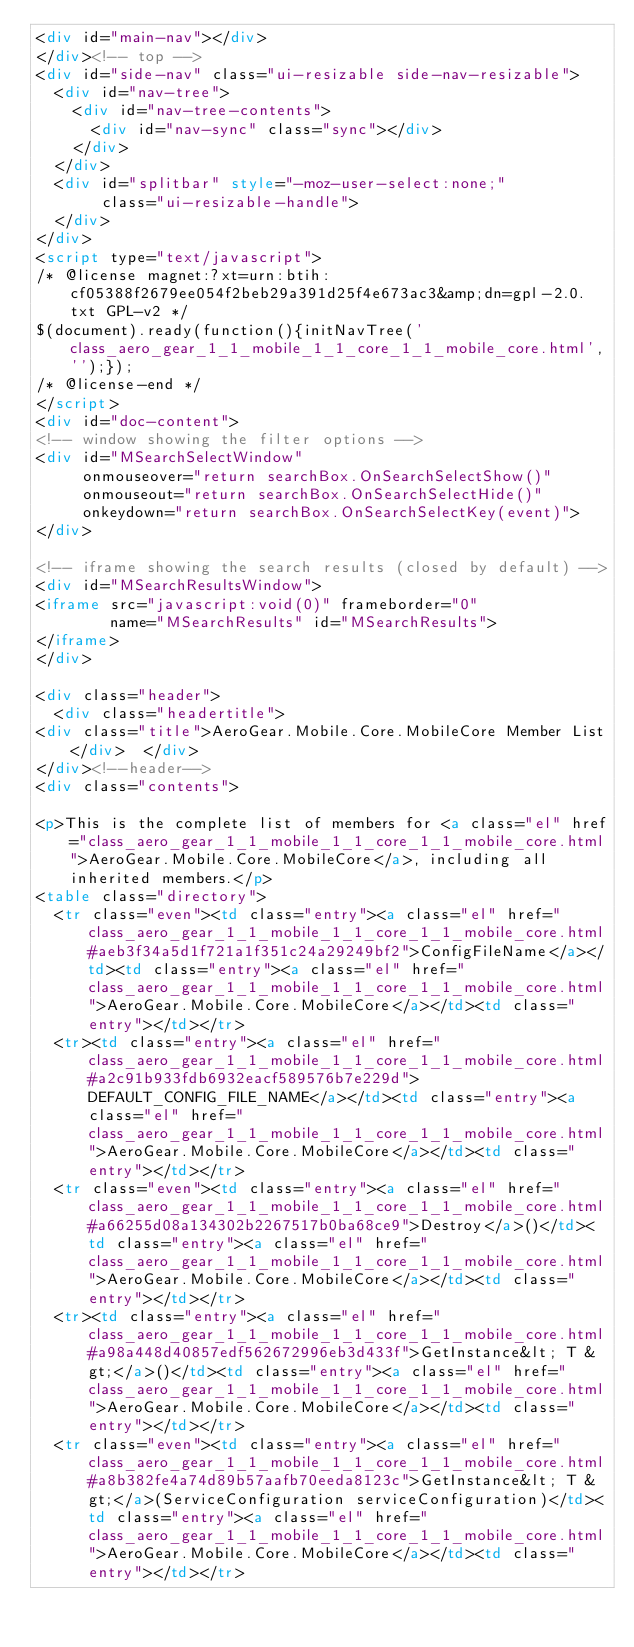Convert code to text. <code><loc_0><loc_0><loc_500><loc_500><_HTML_><div id="main-nav"></div>
</div><!-- top -->
<div id="side-nav" class="ui-resizable side-nav-resizable">
  <div id="nav-tree">
    <div id="nav-tree-contents">
      <div id="nav-sync" class="sync"></div>
    </div>
  </div>
  <div id="splitbar" style="-moz-user-select:none;" 
       class="ui-resizable-handle">
  </div>
</div>
<script type="text/javascript">
/* @license magnet:?xt=urn:btih:cf05388f2679ee054f2beb29a391d25f4e673ac3&amp;dn=gpl-2.0.txt GPL-v2 */
$(document).ready(function(){initNavTree('class_aero_gear_1_1_mobile_1_1_core_1_1_mobile_core.html','');});
/* @license-end */
</script>
<div id="doc-content">
<!-- window showing the filter options -->
<div id="MSearchSelectWindow"
     onmouseover="return searchBox.OnSearchSelectShow()"
     onmouseout="return searchBox.OnSearchSelectHide()"
     onkeydown="return searchBox.OnSearchSelectKey(event)">
</div>

<!-- iframe showing the search results (closed by default) -->
<div id="MSearchResultsWindow">
<iframe src="javascript:void(0)" frameborder="0" 
        name="MSearchResults" id="MSearchResults">
</iframe>
</div>

<div class="header">
  <div class="headertitle">
<div class="title">AeroGear.Mobile.Core.MobileCore Member List</div>  </div>
</div><!--header-->
<div class="contents">

<p>This is the complete list of members for <a class="el" href="class_aero_gear_1_1_mobile_1_1_core_1_1_mobile_core.html">AeroGear.Mobile.Core.MobileCore</a>, including all inherited members.</p>
<table class="directory">
  <tr class="even"><td class="entry"><a class="el" href="class_aero_gear_1_1_mobile_1_1_core_1_1_mobile_core.html#aeb3f34a5d1f721a1f351c24a29249bf2">ConfigFileName</a></td><td class="entry"><a class="el" href="class_aero_gear_1_1_mobile_1_1_core_1_1_mobile_core.html">AeroGear.Mobile.Core.MobileCore</a></td><td class="entry"></td></tr>
  <tr><td class="entry"><a class="el" href="class_aero_gear_1_1_mobile_1_1_core_1_1_mobile_core.html#a2c91b933fdb6932eacf589576b7e229d">DEFAULT_CONFIG_FILE_NAME</a></td><td class="entry"><a class="el" href="class_aero_gear_1_1_mobile_1_1_core_1_1_mobile_core.html">AeroGear.Mobile.Core.MobileCore</a></td><td class="entry"></td></tr>
  <tr class="even"><td class="entry"><a class="el" href="class_aero_gear_1_1_mobile_1_1_core_1_1_mobile_core.html#a66255d08a134302b2267517b0ba68ce9">Destroy</a>()</td><td class="entry"><a class="el" href="class_aero_gear_1_1_mobile_1_1_core_1_1_mobile_core.html">AeroGear.Mobile.Core.MobileCore</a></td><td class="entry"></td></tr>
  <tr><td class="entry"><a class="el" href="class_aero_gear_1_1_mobile_1_1_core_1_1_mobile_core.html#a98a448d40857edf562672996eb3d433f">GetInstance&lt; T &gt;</a>()</td><td class="entry"><a class="el" href="class_aero_gear_1_1_mobile_1_1_core_1_1_mobile_core.html">AeroGear.Mobile.Core.MobileCore</a></td><td class="entry"></td></tr>
  <tr class="even"><td class="entry"><a class="el" href="class_aero_gear_1_1_mobile_1_1_core_1_1_mobile_core.html#a8b382fe4a74d89b57aafb70eeda8123c">GetInstance&lt; T &gt;</a>(ServiceConfiguration serviceConfiguration)</td><td class="entry"><a class="el" href="class_aero_gear_1_1_mobile_1_1_core_1_1_mobile_core.html">AeroGear.Mobile.Core.MobileCore</a></td><td class="entry"></td></tr></code> 